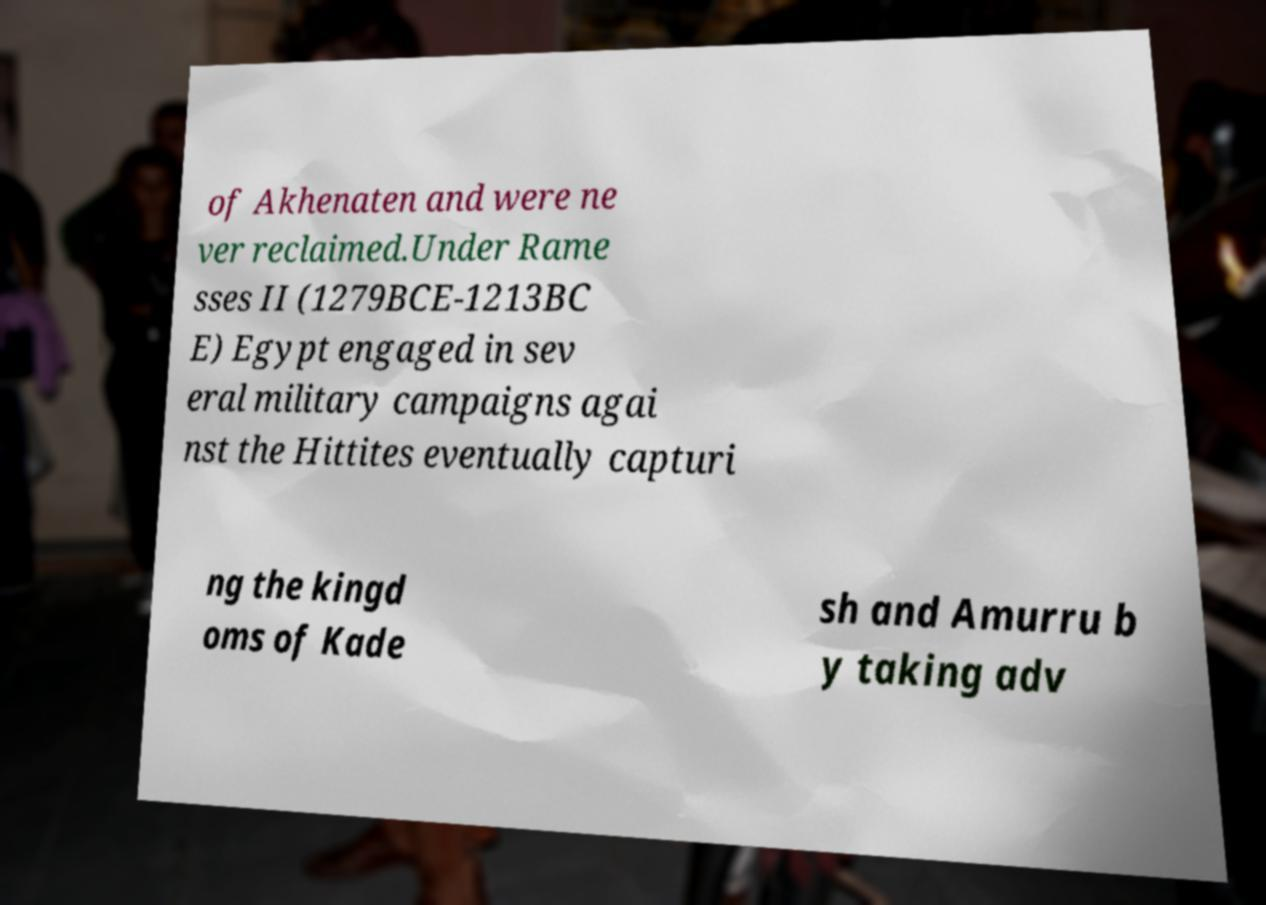I need the written content from this picture converted into text. Can you do that? of Akhenaten and were ne ver reclaimed.Under Rame sses II (1279BCE-1213BC E) Egypt engaged in sev eral military campaigns agai nst the Hittites eventually capturi ng the kingd oms of Kade sh and Amurru b y taking adv 